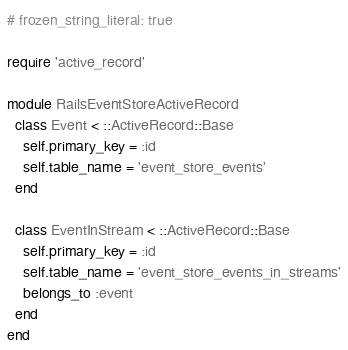Convert code to text. <code><loc_0><loc_0><loc_500><loc_500><_Ruby_># frozen_string_literal: true

require 'active_record'

module RailsEventStoreActiveRecord
  class Event < ::ActiveRecord::Base
    self.primary_key = :id
    self.table_name = 'event_store_events'
  end

  class EventInStream < ::ActiveRecord::Base
    self.primary_key = :id
    self.table_name = 'event_store_events_in_streams'
    belongs_to :event
  end
end
</code> 